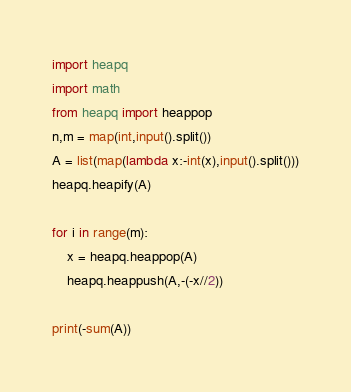Convert code to text. <code><loc_0><loc_0><loc_500><loc_500><_Python_>import heapq
import math
from heapq import heappop
n,m = map(int,input().split())
A = list(map(lambda x:-int(x),input().split()))
heapq.heapify(A)

for i in range(m):
    x = heapq.heappop(A)
    heapq.heappush(A,-(-x//2))

print(-sum(A))</code> 